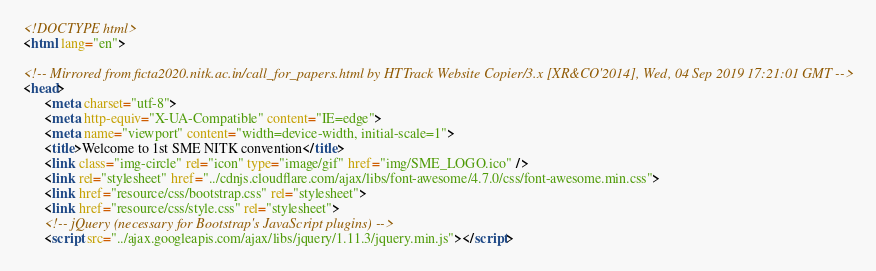<code> <loc_0><loc_0><loc_500><loc_500><_HTML_><!DOCTYPE html>
<html lang="en">
   
<!-- Mirrored from ficta2020.nitk.ac.in/call_for_papers.html by HTTrack Website Copier/3.x [XR&CO'2014], Wed, 04 Sep 2019 17:21:01 GMT -->
<head>
      <meta charset="utf-8">
      <meta http-equiv="X-UA-Compatible" content="IE=edge">
      <meta name="viewport" content="width=device-width, initial-scale=1">
      <title>Welcome to 1st SME NITK convention</title>
      <link class="img-circle" rel="icon" type="image/gif" href="img/SME_LOGO.ico" />
      <link rel="stylesheet" href="../cdnjs.cloudflare.com/ajax/libs/font-awesome/4.7.0/css/font-awesome.min.css">
      <link href="resource/css/bootstrap.css" rel="stylesheet">
      <link href="resource/css/style.css" rel="stylesheet">
      <!-- jQuery (necessary for Bootstrap's JavaScript plugins) -->
      <script src="../ajax.googleapis.com/ajax/libs/jquery/1.11.3/jquery.min.js"></script></code> 